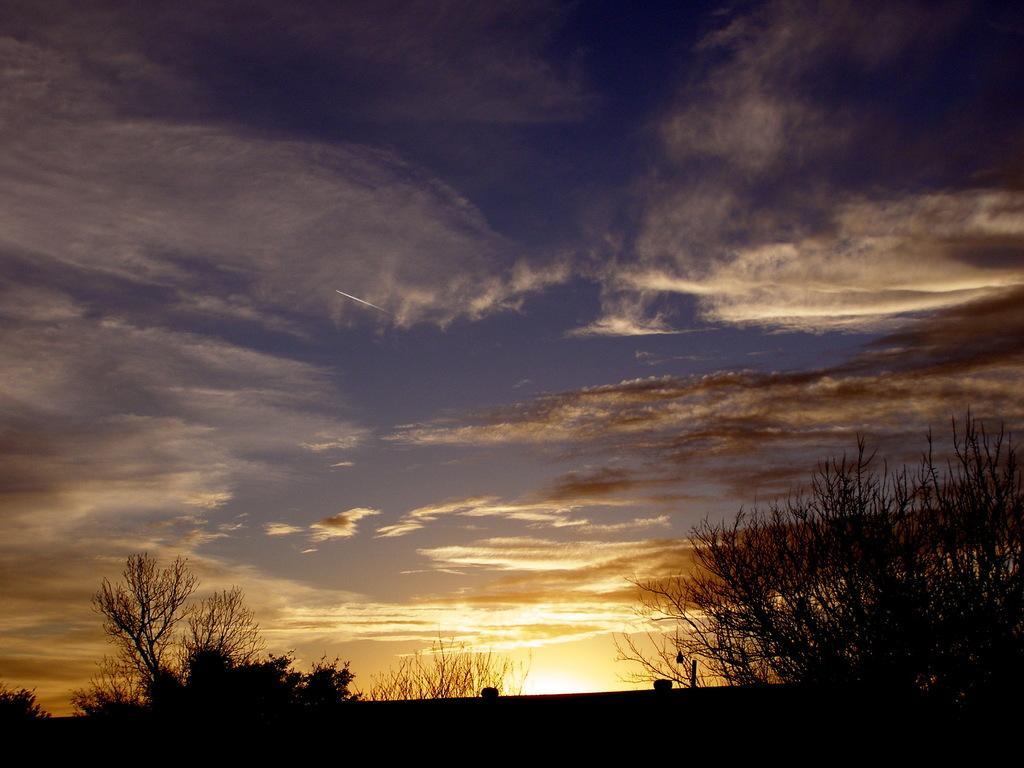Please provide a concise description of this image. In the image there are plants and in the background there is a sky. 